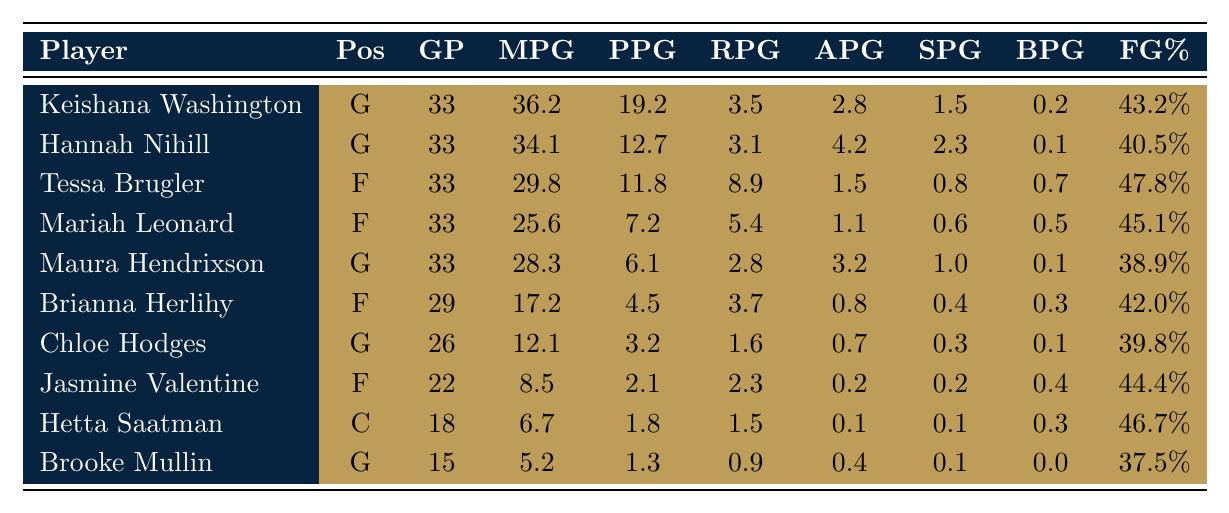What is the average points per game for the team? To find the average points per game, sum the points per game for all players: 19.2 + 12.7 + 11.8 + 7.2 + 6.1 + 4.5 + 3.2 + 2.1 + 1.8 + 1.3 = 69.9. There are 10 players, so the average is 69.9 / 10 = 6.99.
Answer: 6.99 Who had the highest field goal percentage? Looking at the field goal percentages, Tessa Brugler has the highest percentage at 47.8%.
Answer: Tessa Brugler How many games did Brianna Herlihy play? Brianna Herlihy played in a total of 29 games as listed in the table.
Answer: 29 Is the average rebounds per game for guards greater than 3? First, calculate the average rebounds per game for the guards. The guards are Keishana Washington, Hannah Nihill, Maura Hendrixson, and Chloe Hodges with rebounds 3.5, 3.1, 2.8, and 1.6 respectively. Their sum is 3.5 + 3.1 + 2.8 + 1.6 = 11. So the average is 11 / 4 = 2.75, which is less than 3.
Answer: No What is the total number of assists made by all players? To find the total number of assists, sum the assists per game for all players: 2.8 + 4.2 + 1.5 + 1.1 + 3.2 + 0.8 + 0.7 + 0.2 + 0.1 + 0.4 = 15.9.
Answer: 15.9 Which player had the lowest points per game? Looking at the points per game statistics, Brooke Mullin had the lowest at 1.3 points per game.
Answer: Brooke Mullin Is there a player with more than 2 blocks per game? Reviewing the blocks per game statistics, no player has more than 2 blocks. The highest is 0.7 by Tessa Brugler.
Answer: No What is the difference in average minutes per game between the highest and lowest minute players? The highest is Keishana Washington at 36.2 minutes, and the lowest is Brooke Mullin at 5.2 minutes. Their difference is 36.2 - 5.2 = 31.
Answer: 31 How many players scored an average of 6 or more points per game? The players who scored 6 or more points per game are Keishana Washington, Hannah Nihill, Tessa Brugler, and Mariah Leonard. This totals 4 players.
Answer: 4 